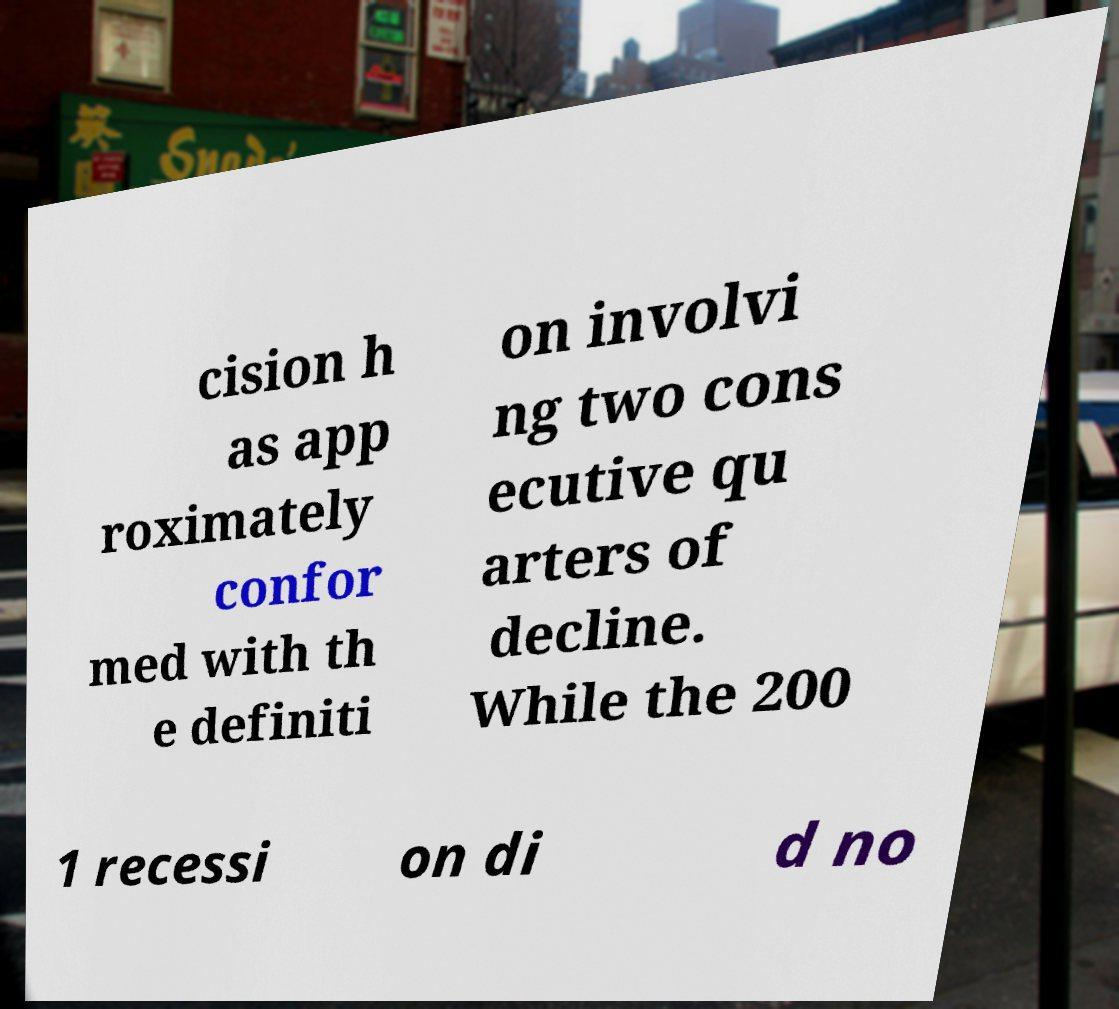I need the written content from this picture converted into text. Can you do that? cision h as app roximately confor med with th e definiti on involvi ng two cons ecutive qu arters of decline. While the 200 1 recessi on di d no 